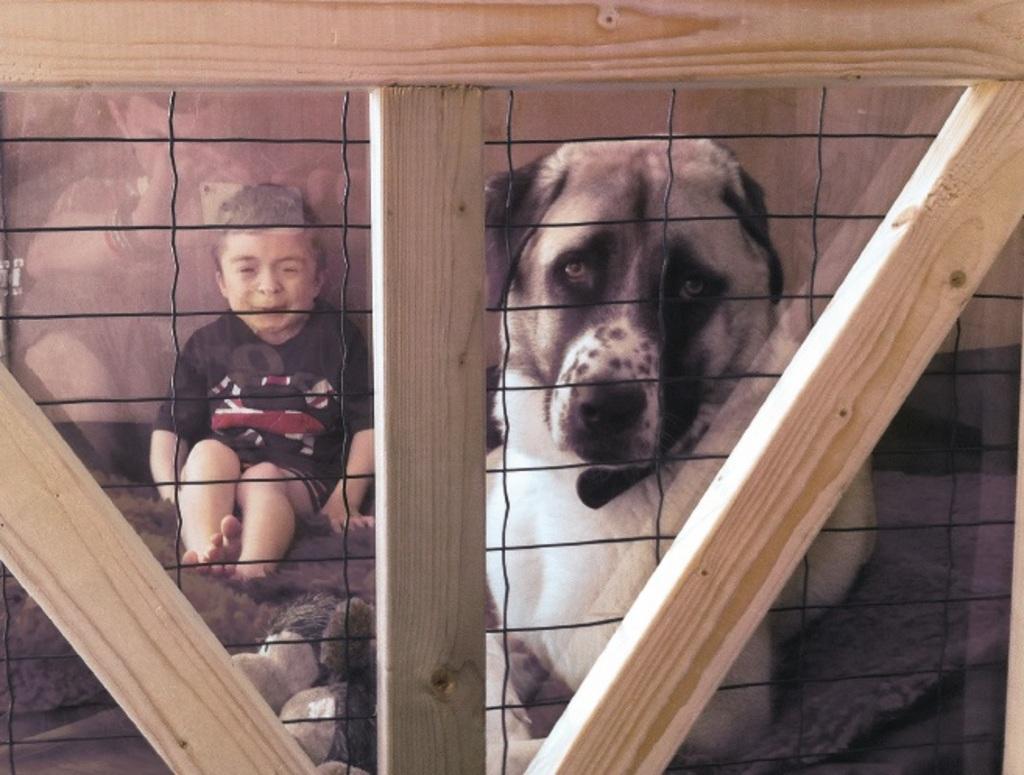Could you give a brief overview of what you see in this image? In this picture I can see there is a boy and a dog sitting on the floor and there is a wooden frame and a fence. 